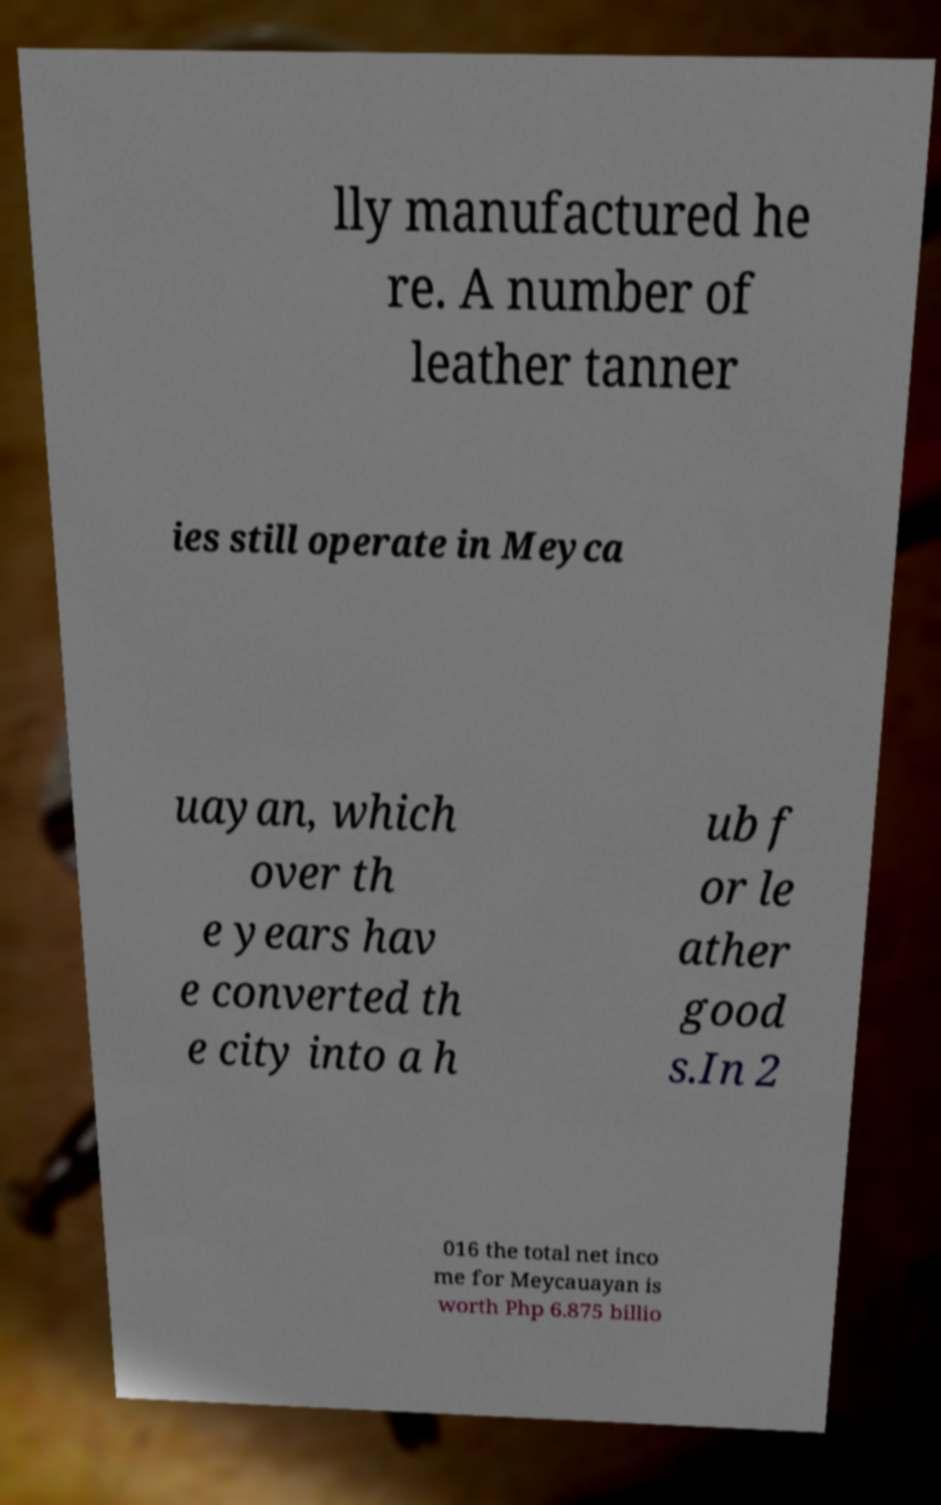Can you read and provide the text displayed in the image?This photo seems to have some interesting text. Can you extract and type it out for me? lly manufactured he re. A number of leather tanner ies still operate in Meyca uayan, which over th e years hav e converted th e city into a h ub f or le ather good s.In 2 016 the total net inco me for Meycauayan is worth Php 6.875 billio 